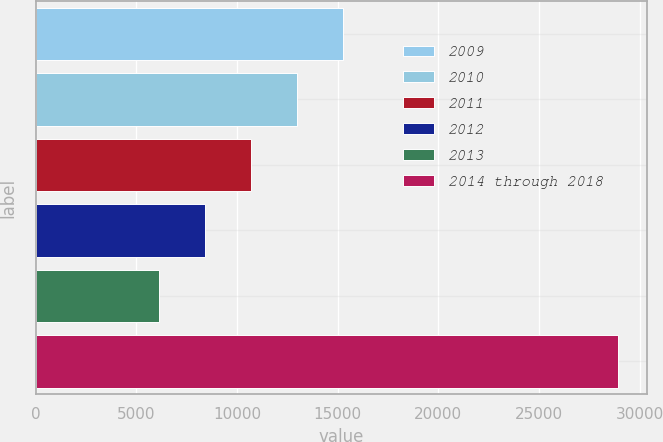Convert chart. <chart><loc_0><loc_0><loc_500><loc_500><bar_chart><fcel>2009<fcel>2010<fcel>2011<fcel>2012<fcel>2013<fcel>2014 through 2018<nl><fcel>15243<fcel>12964<fcel>10685<fcel>8406<fcel>6127<fcel>28917<nl></chart> 